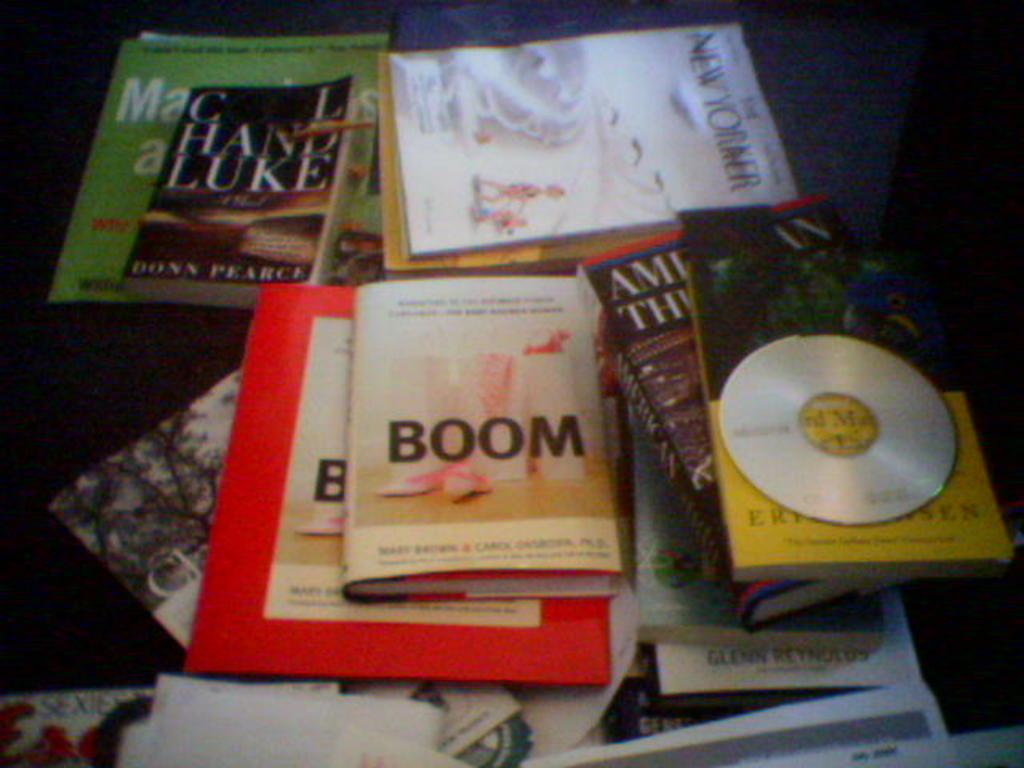<image>
Present a compact description of the photo's key features. Many books on a table including one that says BOOM on the cover. 